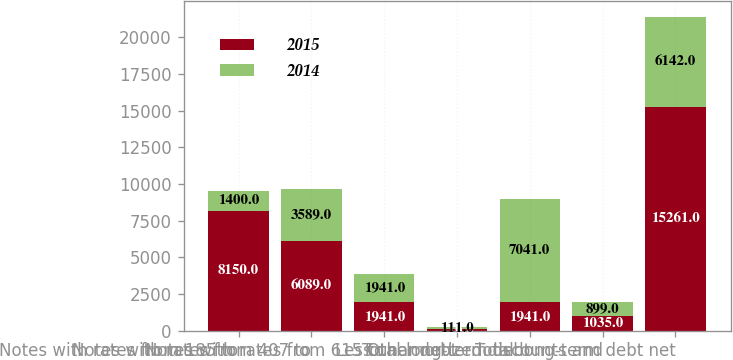<chart> <loc_0><loc_0><loc_500><loc_500><stacked_bar_chart><ecel><fcel>Notes with rates from 185 to<fcel>Notes with rates from 407 to<fcel>Notes with rates from 615 to<fcel>Other debt<fcel>Total long-term debt<fcel>Less unamortized discounts and<fcel>Total long-term debt net<nl><fcel>2015<fcel>8150<fcel>6089<fcel>1941<fcel>116<fcel>1941<fcel>1035<fcel>15261<nl><fcel>2014<fcel>1400<fcel>3589<fcel>1941<fcel>111<fcel>7041<fcel>899<fcel>6142<nl></chart> 